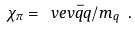Convert formula to latex. <formula><loc_0><loc_0><loc_500><loc_500>\chi _ { \pi } = \ v e v { \bar { q } q } / m _ { q } \ .</formula> 